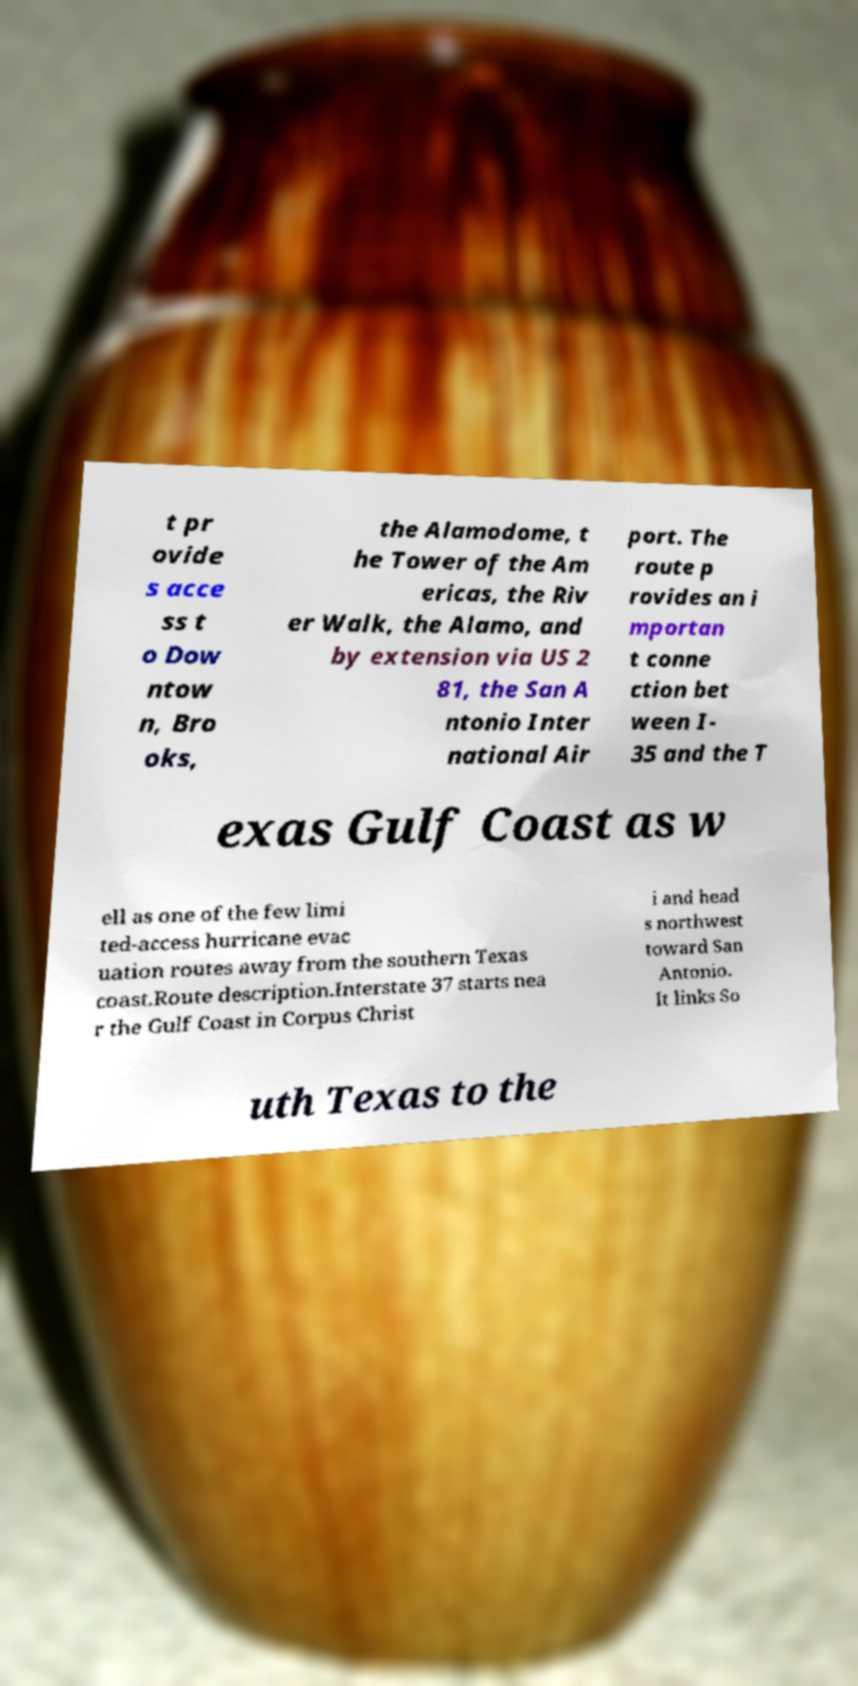What messages or text are displayed in this image? I need them in a readable, typed format. t pr ovide s acce ss t o Dow ntow n, Bro oks, the Alamodome, t he Tower of the Am ericas, the Riv er Walk, the Alamo, and by extension via US 2 81, the San A ntonio Inter national Air port. The route p rovides an i mportan t conne ction bet ween I- 35 and the T exas Gulf Coast as w ell as one of the few limi ted-access hurricane evac uation routes away from the southern Texas coast.Route description.Interstate 37 starts nea r the Gulf Coast in Corpus Christ i and head s northwest toward San Antonio. It links So uth Texas to the 